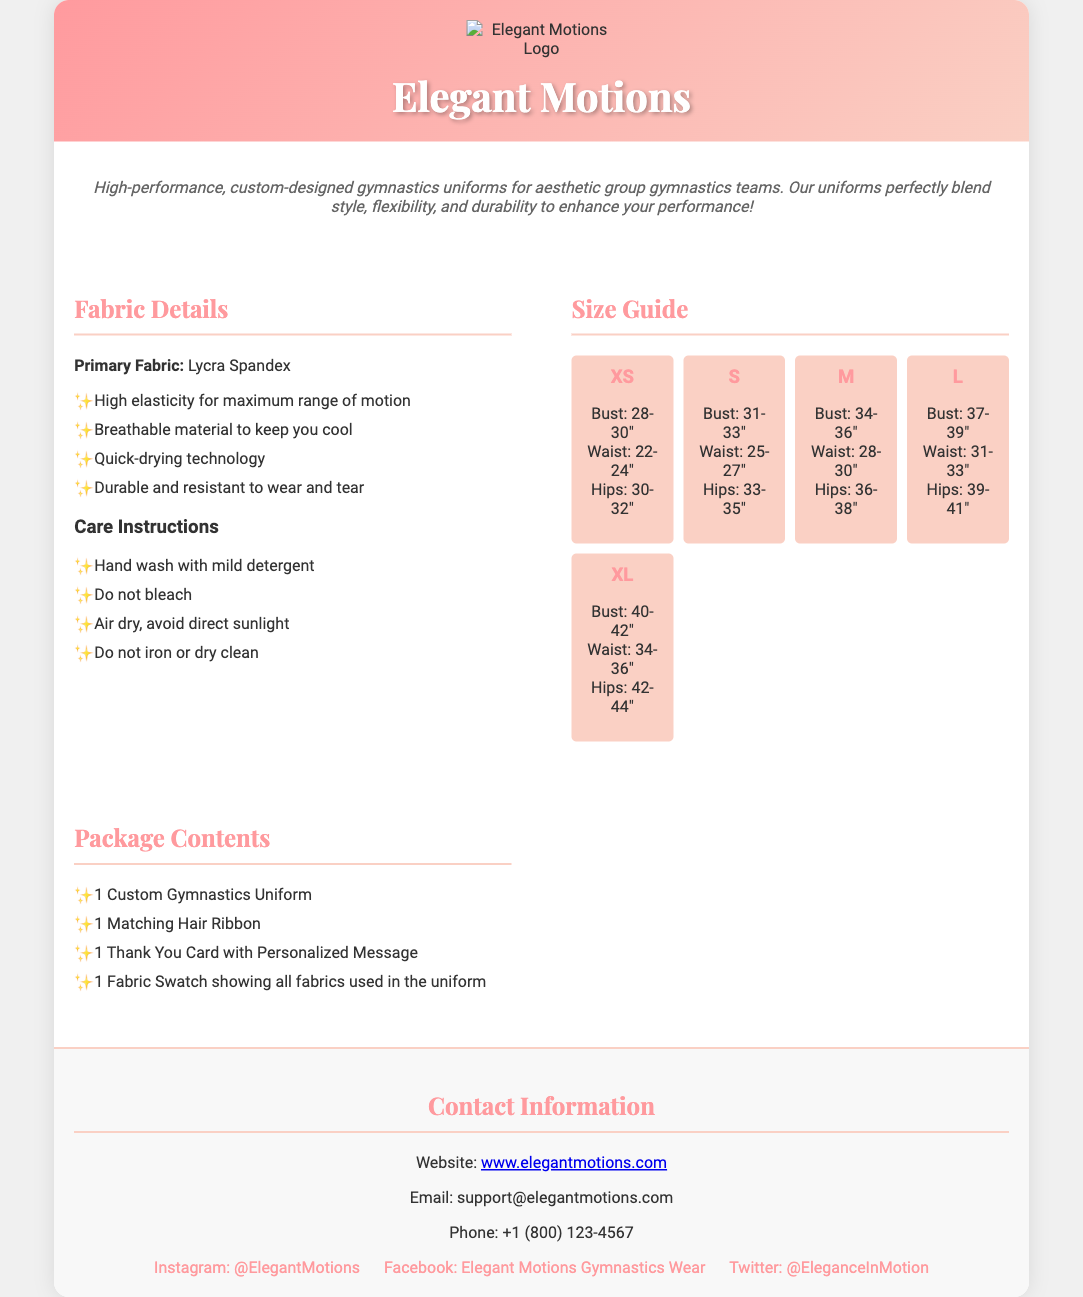What is the primary fabric used? The primary fabric used for the uniforms is mentioned in the "Fabric Details" section.
Answer: Lycra Spandex What sizes are available for the gymnastics uniforms? The sizes listed in the "Size Guide" section cover the available options.
Answer: XS, S, M, L, XL What is the bust measurement for size M? The bust measurement for size M is provided in the "Size Guide" section.
Answer: 34-36 inches How many items are included in the package? The "Package Contents" section lists the number of items included in the package.
Answer: 4 What is the care instruction for washing? The care instruction for washing details are given in the "Care Instructions" subsection.
Answer: Hand wash with mild detergent What color is the header background? The header background color of the document is described in the style section of the code.
Answer: Linear gradient of pink shades What type of company is Elegant Motions? The description section specifies the type of products offered by the company.
Answer: Custom gymnastics uniforms What is included as a personalized thank you? The "Package Contents" section states what type of personalized message is included.
Answer: Thank You Card with Personalized Message What is the Instagram handle for Elegant Motions? The Instagram handle is provided in the "Contact Information" section.
Answer: @ElegantMotions 